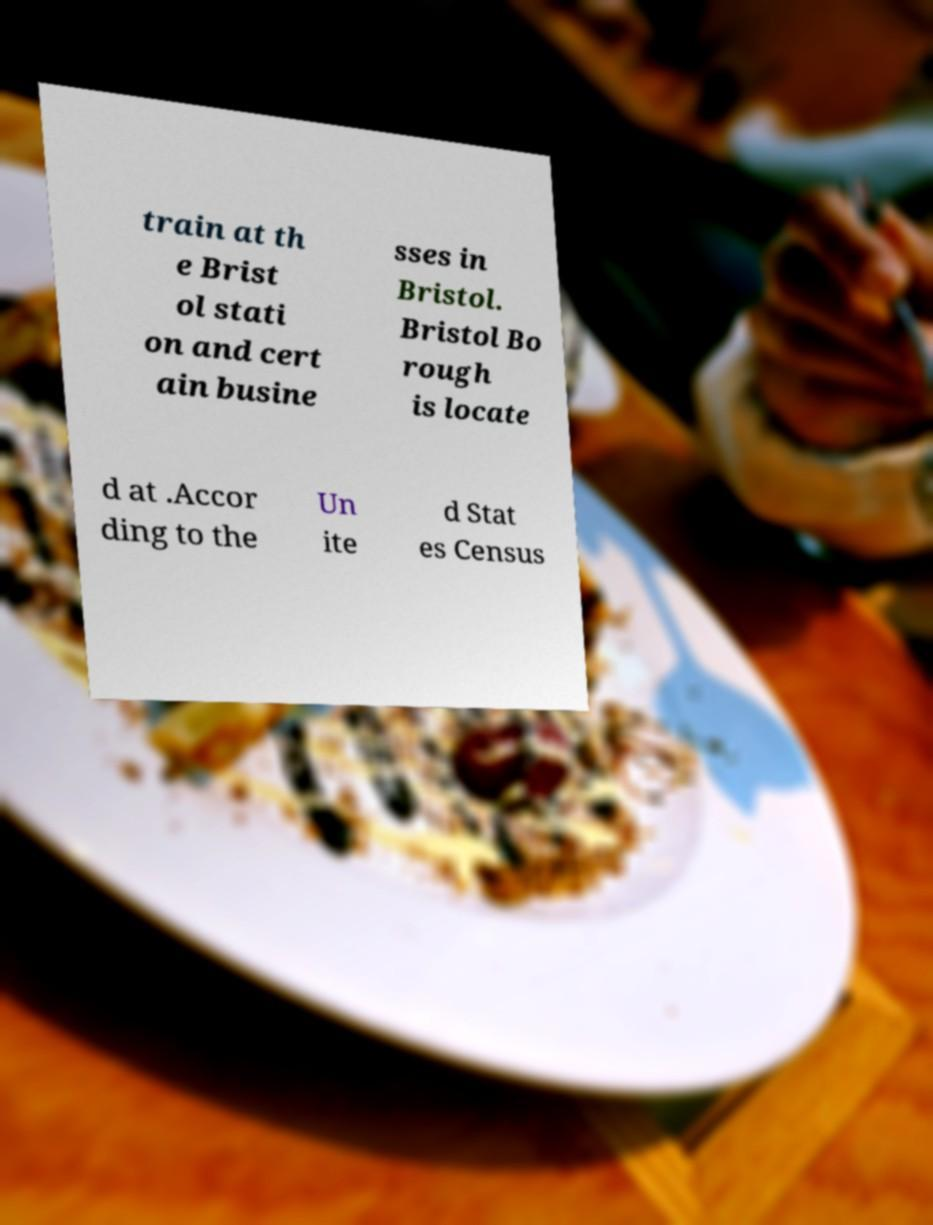Can you accurately transcribe the text from the provided image for me? train at th e Brist ol stati on and cert ain busine sses in Bristol. Bristol Bo rough is locate d at .Accor ding to the Un ite d Stat es Census 